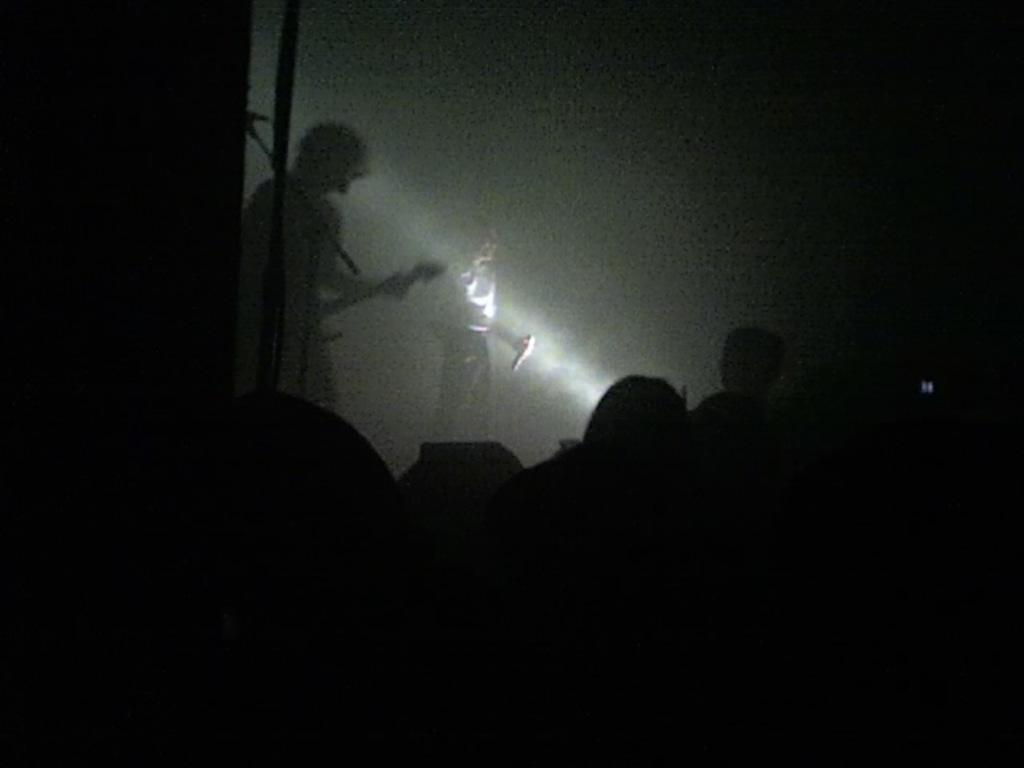Describe this image in one or two sentences. In this picture we can see few people, in the background we can see a person is playing guitar and a woman is holding a microphone. 